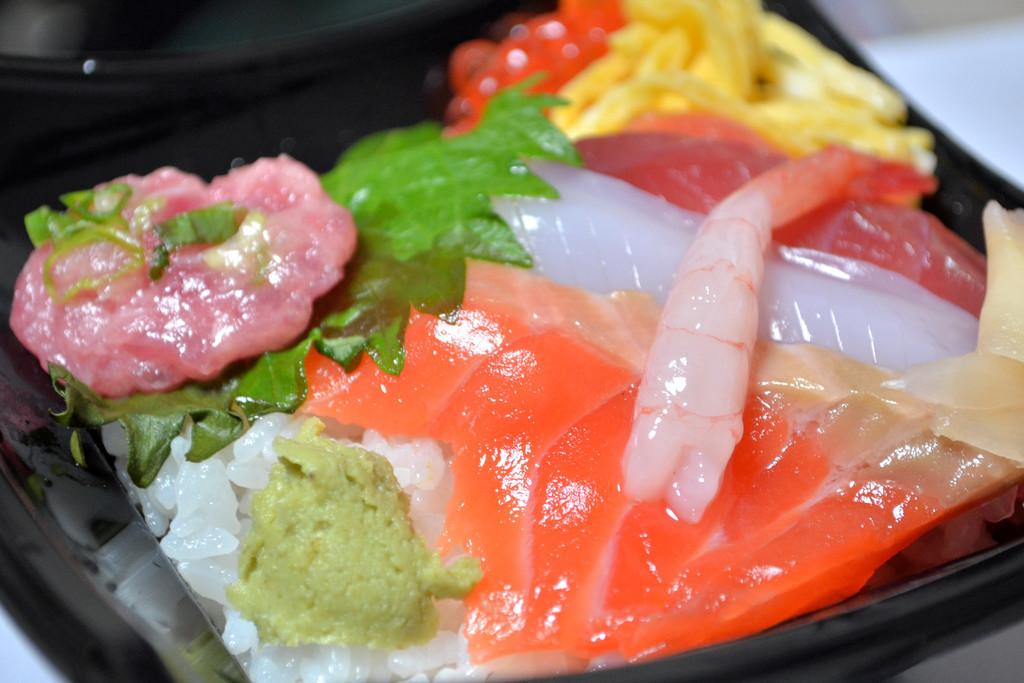What is the main subject of the image? The image is a zoomed-in picture of a food item. What can be observed about the plate the food item is on? The food item is on a black plate. What is the color of the surface beneath the black plate? The black plate is on a white surface. Can you see any snails crawling on the food item in the image? No, there are no snails present in the image. What type of arch can be seen in the background of the image? There is no arch visible in the background of the image; it is a close-up of a food item on a plate. 